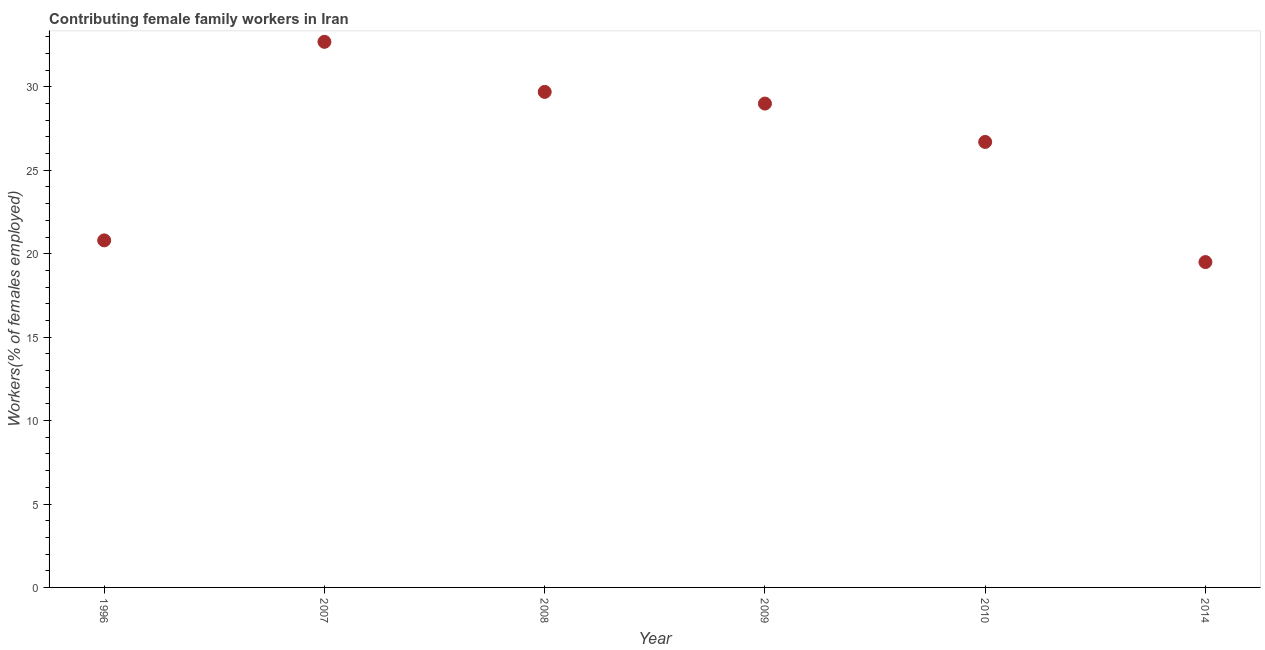What is the contributing female family workers in 2008?
Your answer should be compact. 29.7. Across all years, what is the maximum contributing female family workers?
Ensure brevity in your answer.  32.7. Across all years, what is the minimum contributing female family workers?
Ensure brevity in your answer.  19.5. In which year was the contributing female family workers maximum?
Your response must be concise. 2007. What is the sum of the contributing female family workers?
Provide a short and direct response. 158.4. What is the difference between the contributing female family workers in 1996 and 2007?
Your response must be concise. -11.9. What is the average contributing female family workers per year?
Offer a terse response. 26.4. What is the median contributing female family workers?
Your answer should be very brief. 27.85. In how many years, is the contributing female family workers greater than 3 %?
Keep it short and to the point. 6. What is the ratio of the contributing female family workers in 2007 to that in 2010?
Give a very brief answer. 1.22. Is the contributing female family workers in 2008 less than that in 2009?
Make the answer very short. No. Is the difference between the contributing female family workers in 2008 and 2010 greater than the difference between any two years?
Give a very brief answer. No. What is the difference between the highest and the second highest contributing female family workers?
Give a very brief answer. 3. Is the sum of the contributing female family workers in 2008 and 2010 greater than the maximum contributing female family workers across all years?
Make the answer very short. Yes. What is the difference between the highest and the lowest contributing female family workers?
Offer a very short reply. 13.2. In how many years, is the contributing female family workers greater than the average contributing female family workers taken over all years?
Provide a succinct answer. 4. Does the contributing female family workers monotonically increase over the years?
Provide a succinct answer. No. Does the graph contain any zero values?
Make the answer very short. No. Does the graph contain grids?
Make the answer very short. No. What is the title of the graph?
Your response must be concise. Contributing female family workers in Iran. What is the label or title of the Y-axis?
Ensure brevity in your answer.  Workers(% of females employed). What is the Workers(% of females employed) in 1996?
Provide a short and direct response. 20.8. What is the Workers(% of females employed) in 2007?
Your answer should be compact. 32.7. What is the Workers(% of females employed) in 2008?
Make the answer very short. 29.7. What is the Workers(% of females employed) in 2010?
Offer a very short reply. 26.7. What is the difference between the Workers(% of females employed) in 1996 and 2007?
Your answer should be very brief. -11.9. What is the difference between the Workers(% of females employed) in 1996 and 2008?
Ensure brevity in your answer.  -8.9. What is the difference between the Workers(% of females employed) in 2007 and 2009?
Provide a succinct answer. 3.7. What is the difference between the Workers(% of females employed) in 2007 and 2010?
Your answer should be compact. 6. What is the difference between the Workers(% of females employed) in 2007 and 2014?
Make the answer very short. 13.2. What is the difference between the Workers(% of females employed) in 2008 and 2009?
Ensure brevity in your answer.  0.7. What is the difference between the Workers(% of females employed) in 2008 and 2014?
Your answer should be very brief. 10.2. What is the ratio of the Workers(% of females employed) in 1996 to that in 2007?
Your answer should be compact. 0.64. What is the ratio of the Workers(% of females employed) in 1996 to that in 2009?
Give a very brief answer. 0.72. What is the ratio of the Workers(% of females employed) in 1996 to that in 2010?
Keep it short and to the point. 0.78. What is the ratio of the Workers(% of females employed) in 1996 to that in 2014?
Provide a short and direct response. 1.07. What is the ratio of the Workers(% of females employed) in 2007 to that in 2008?
Provide a succinct answer. 1.1. What is the ratio of the Workers(% of females employed) in 2007 to that in 2009?
Give a very brief answer. 1.13. What is the ratio of the Workers(% of females employed) in 2007 to that in 2010?
Your answer should be compact. 1.23. What is the ratio of the Workers(% of females employed) in 2007 to that in 2014?
Your response must be concise. 1.68. What is the ratio of the Workers(% of females employed) in 2008 to that in 2009?
Provide a succinct answer. 1.02. What is the ratio of the Workers(% of females employed) in 2008 to that in 2010?
Your response must be concise. 1.11. What is the ratio of the Workers(% of females employed) in 2008 to that in 2014?
Offer a terse response. 1.52. What is the ratio of the Workers(% of females employed) in 2009 to that in 2010?
Give a very brief answer. 1.09. What is the ratio of the Workers(% of females employed) in 2009 to that in 2014?
Your answer should be very brief. 1.49. What is the ratio of the Workers(% of females employed) in 2010 to that in 2014?
Make the answer very short. 1.37. 